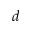Convert formula to latex. <formula><loc_0><loc_0><loc_500><loc_500>d</formula> 